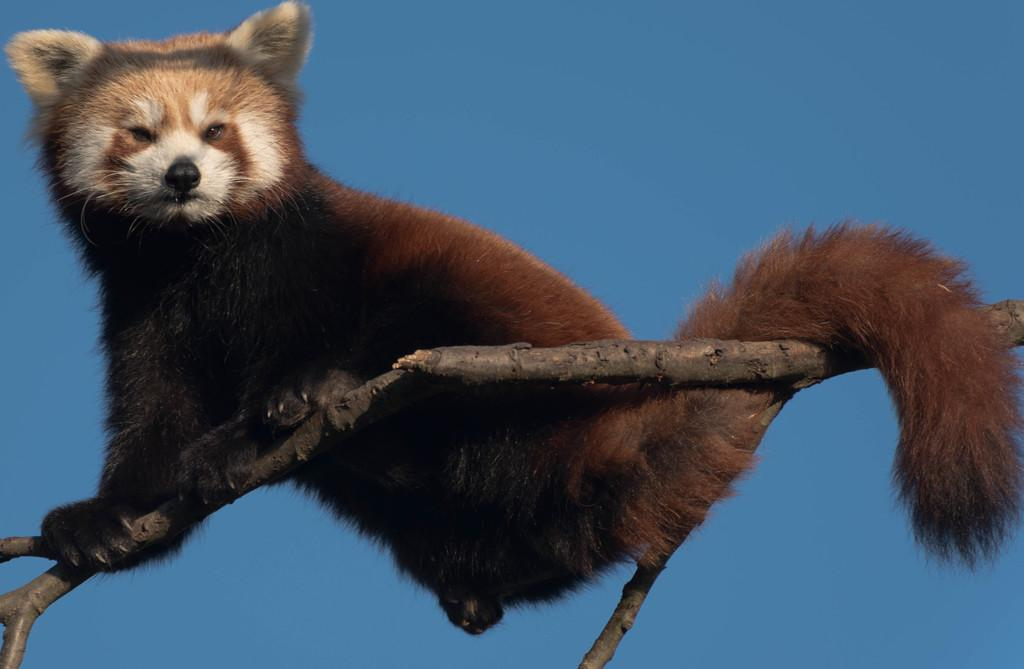What can be seen on the left side of the image? There is an animal on a branch of a tree on the left side of the image. What color is the background of the image? The background of the image is blue in color. Can you tell me how many crooks are present in the image? There are no crooks present in the image; it features an animal on a tree branch and a blue background. What type of joke can be seen in the image? There is no joke present in the image; it is a photograph of an animal on a tree branch with a blue background. 